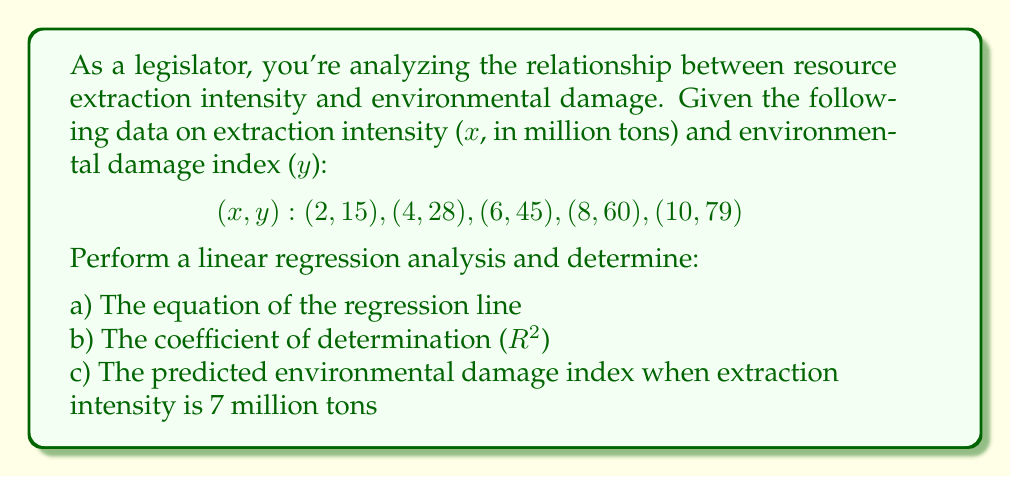Teach me how to tackle this problem. 1) First, let's calculate the means of x and y:
   $\bar{x} = \frac{2 + 4 + 6 + 8 + 10}{5} = 6$
   $\bar{y} = \frac{15 + 28 + 45 + 60 + 79}{5} = 45.4$

2) Calculate the slope (m) of the regression line:
   $$m = \frac{\sum(x_i - \bar{x})(y_i - \bar{y})}{\sum(x_i - \bar{x})^2}$$
   
   Numerator: $(-4)(-30.4) + (-2)(-17.4) + (0)(-0.4) + (2)(14.6) + (4)(33.6) = 324$
   Denominator: $(-4)^2 + (-2)^2 + (0)^2 + (2)^2 + (4)^2 = 40$
   
   $m = \frac{324}{40} = 8.1$

3) Calculate the y-intercept (b):
   $b = \bar{y} - m\bar{x} = 45.4 - 8.1(6) = -3.2$

4) The regression line equation is:
   $y = 8.1x - 3.2$

5) Calculate $R^2$:
   $$R^2 = \frac{(\sum(x_i - \bar{x})(y_i - \bar{y}))^2}{\sum(x_i - \bar{x})^2 \sum(y_i - \bar{y})^2}$$
   
   Numerator: $324^2 = 104,976$
   Denominator: $40 * ((-30.4)^2 + (-17.4)^2 + (-0.4)^2 + (14.6)^2 + (33.6)^2) = 40 * 2,624.56 = 104,982.4$
   
   $R^2 = \frac{104,976}{104,982.4} \approx 0.9999$

6) Predict y when x = 7:
   $y = 8.1(7) - 3.2 = 53.5$
Answer: a) $y = 8.1x - 3.2$
b) $R^2 \approx 0.9999$
c) 53.5 